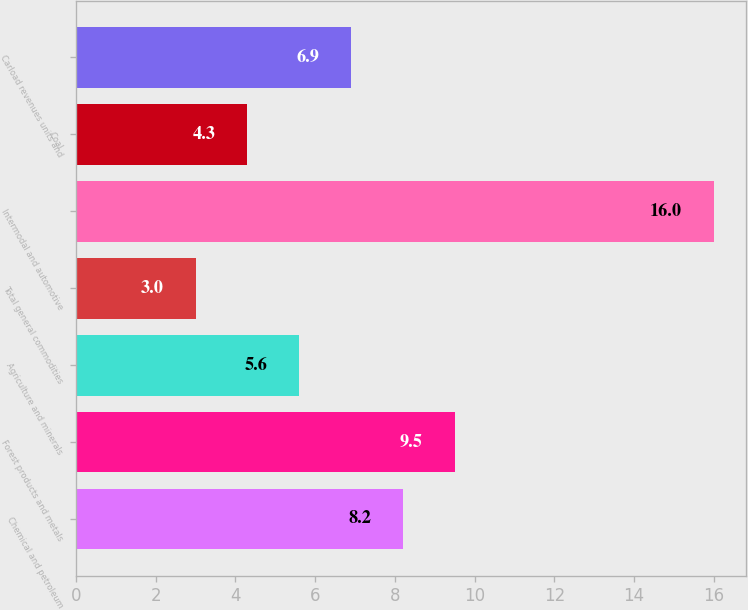<chart> <loc_0><loc_0><loc_500><loc_500><bar_chart><fcel>Chemical and petroleum<fcel>Forest products and metals<fcel>Agriculture and minerals<fcel>Total general commodities<fcel>Intermodal and automotive<fcel>Coal<fcel>Carload revenues units and<nl><fcel>8.2<fcel>9.5<fcel>5.6<fcel>3<fcel>16<fcel>4.3<fcel>6.9<nl></chart> 